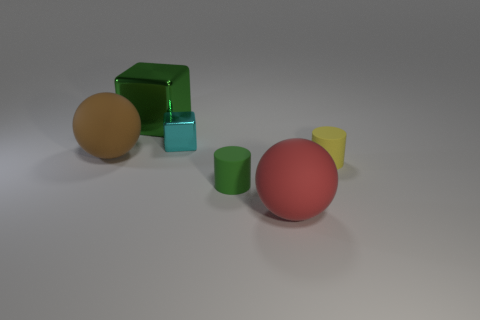Do the small rubber object that is left of the big red rubber object and the large metal object have the same color?
Provide a succinct answer. Yes. Are there any rubber things of the same color as the big block?
Ensure brevity in your answer.  Yes. How many other objects are there of the same size as the brown matte thing?
Your response must be concise. 2. What number of large green objects are made of the same material as the tiny cyan block?
Keep it short and to the point. 1. The big brown thing that is left of the small shiny block has what shape?
Your answer should be very brief. Sphere. Is the cyan object made of the same material as the green object in front of the big shiny cube?
Make the answer very short. No. Are any big cyan matte blocks visible?
Offer a terse response. No. There is a rubber ball to the right of the small thing behind the yellow matte object; are there any tiny yellow cylinders behind it?
Offer a very short reply. Yes. What number of tiny objects are either green things or brown metal blocks?
Ensure brevity in your answer.  1. There is a metallic cube that is the same size as the red sphere; what color is it?
Provide a succinct answer. Green. 